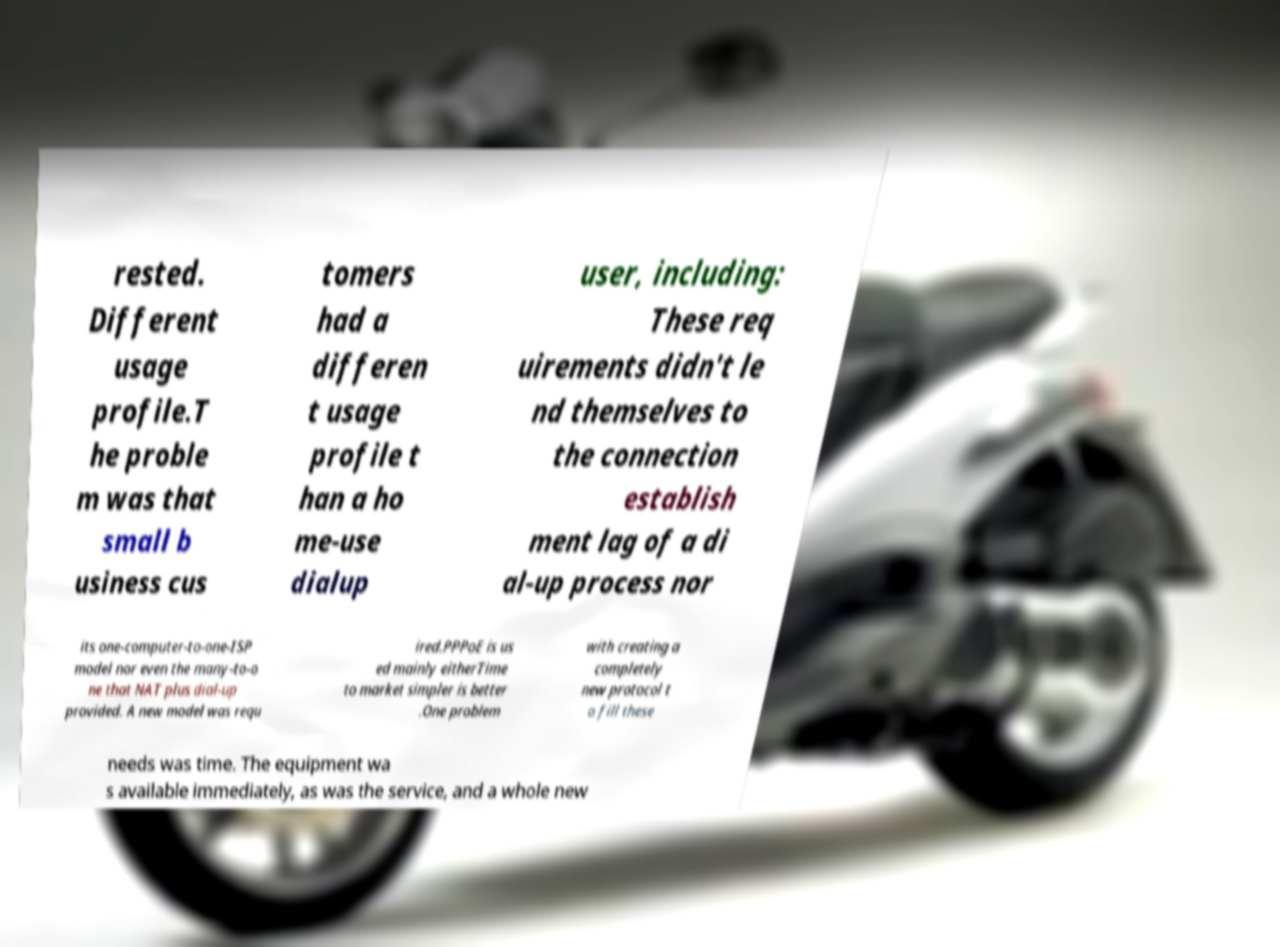Could you extract and type out the text from this image? rested. Different usage profile.T he proble m was that small b usiness cus tomers had a differen t usage profile t han a ho me-use dialup user, including: These req uirements didn't le nd themselves to the connection establish ment lag of a di al-up process nor its one-computer-to-one-ISP model nor even the many-to-o ne that NAT plus dial-up provided. A new model was requ ired.PPPoE is us ed mainly eitherTime to market simpler is better .One problem with creating a completely new protocol t o fill these needs was time. The equipment wa s available immediately, as was the service, and a whole new 